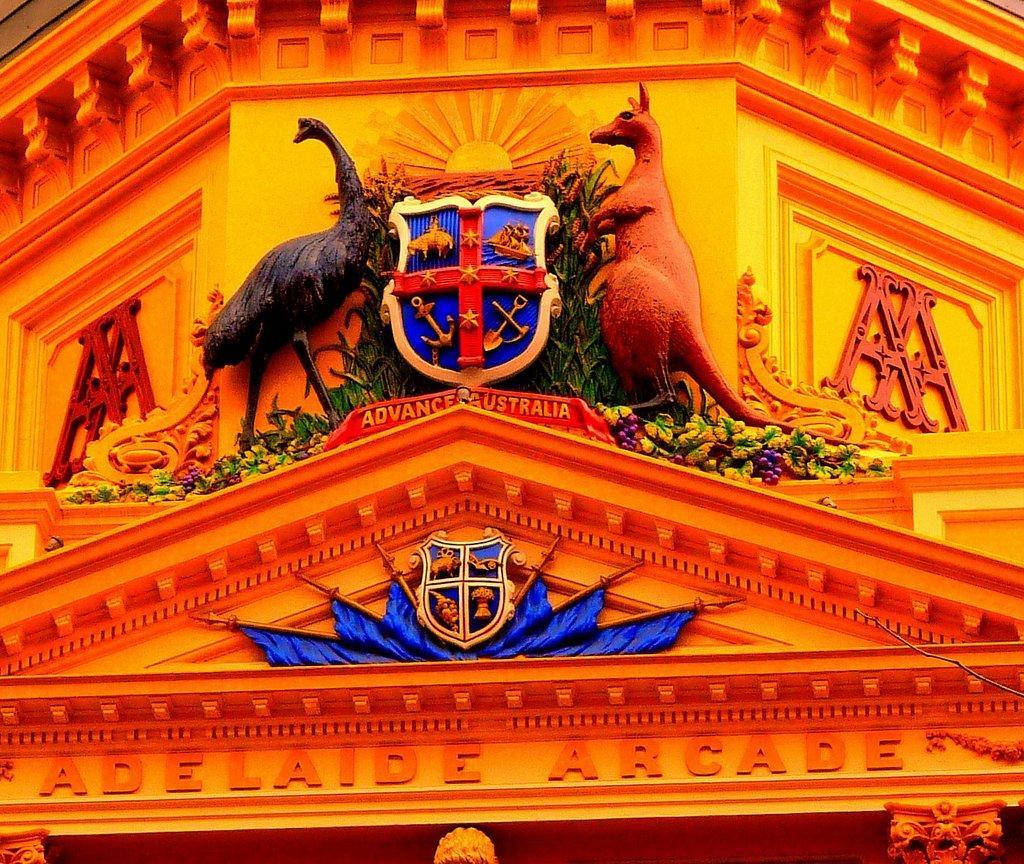Describe this image in one or two sentences. In this image we can see a building, on the building, we can see some text, statues and shields. 